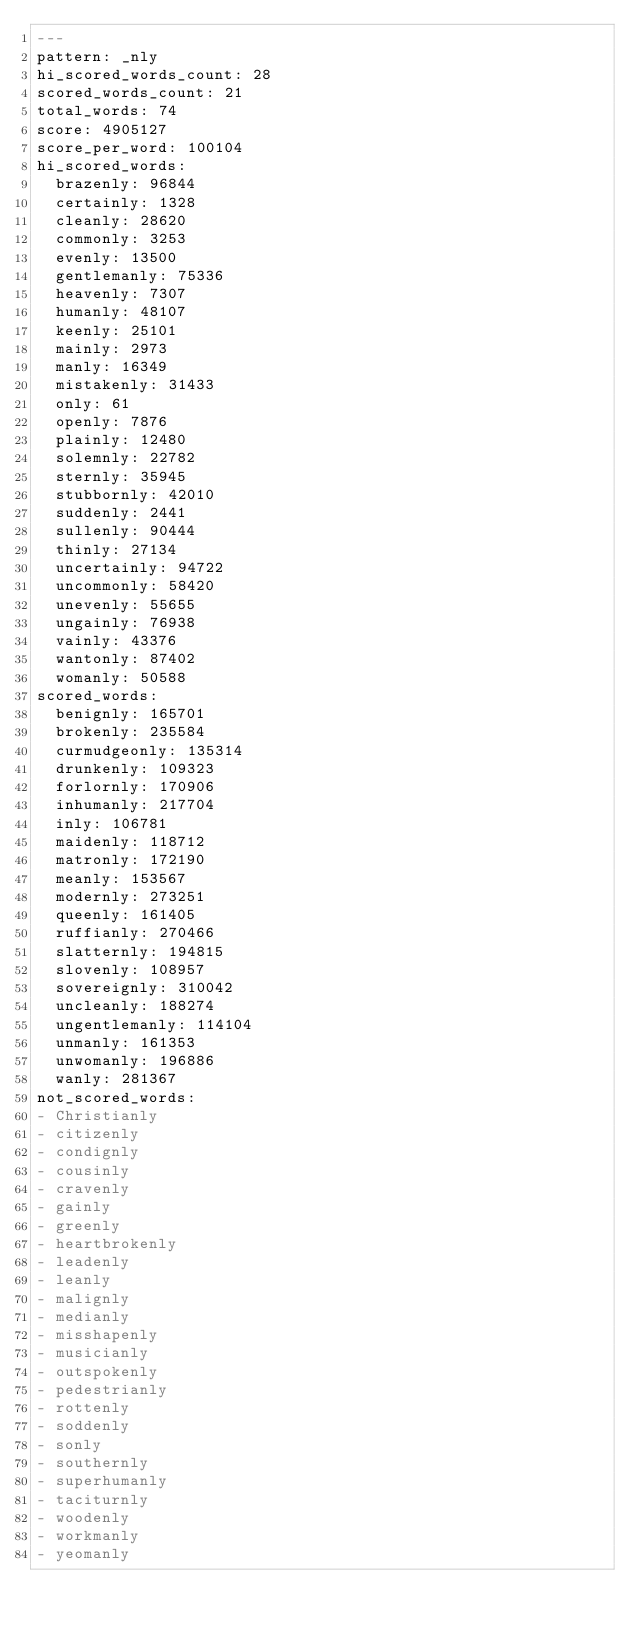<code> <loc_0><loc_0><loc_500><loc_500><_YAML_>---
pattern: _nly
hi_scored_words_count: 28
scored_words_count: 21
total_words: 74
score: 4905127
score_per_word: 100104
hi_scored_words:
  brazenly: 96844
  certainly: 1328
  cleanly: 28620
  commonly: 3253
  evenly: 13500
  gentlemanly: 75336
  heavenly: 7307
  humanly: 48107
  keenly: 25101
  mainly: 2973
  manly: 16349
  mistakenly: 31433
  only: 61
  openly: 7876
  plainly: 12480
  solemnly: 22782
  sternly: 35945
  stubbornly: 42010
  suddenly: 2441
  sullenly: 90444
  thinly: 27134
  uncertainly: 94722
  uncommonly: 58420
  unevenly: 55655
  ungainly: 76938
  vainly: 43376
  wantonly: 87402
  womanly: 50588
scored_words:
  benignly: 165701
  brokenly: 235584
  curmudgeonly: 135314
  drunkenly: 109323
  forlornly: 170906
  inhumanly: 217704
  inly: 106781
  maidenly: 118712
  matronly: 172190
  meanly: 153567
  modernly: 273251
  queenly: 161405
  ruffianly: 270466
  slatternly: 194815
  slovenly: 108957
  sovereignly: 310042
  uncleanly: 188274
  ungentlemanly: 114104
  unmanly: 161353
  unwomanly: 196886
  wanly: 281367
not_scored_words:
- Christianly
- citizenly
- condignly
- cousinly
- cravenly
- gainly
- greenly
- heartbrokenly
- leadenly
- leanly
- malignly
- medianly
- misshapenly
- musicianly
- outspokenly
- pedestrianly
- rottenly
- soddenly
- sonly
- southernly
- superhumanly
- taciturnly
- woodenly
- workmanly
- yeomanly
</code> 